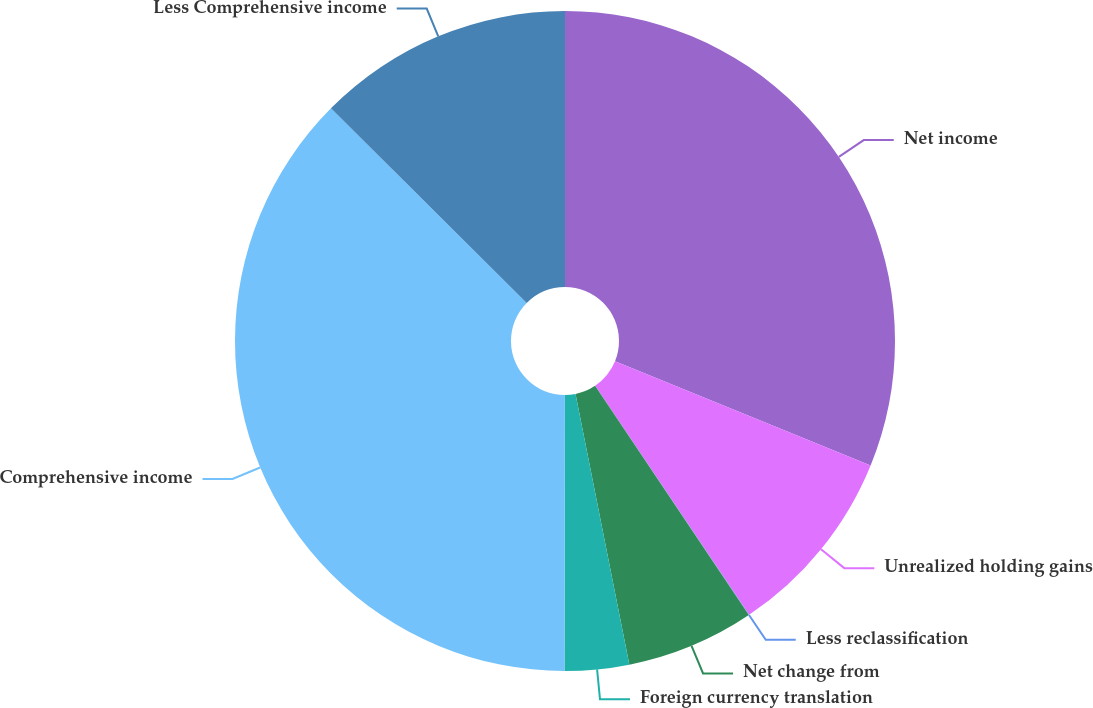Convert chart. <chart><loc_0><loc_0><loc_500><loc_500><pie_chart><fcel>Net income<fcel>Unrealized holding gains<fcel>Less reclassification<fcel>Net change from<fcel>Foreign currency translation<fcel>Comprehensive income<fcel>Less Comprehensive income<nl><fcel>31.16%<fcel>9.42%<fcel>0.02%<fcel>6.28%<fcel>3.15%<fcel>37.43%<fcel>12.55%<nl></chart> 